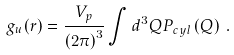Convert formula to latex. <formula><loc_0><loc_0><loc_500><loc_500>g _ { u } ( r ) = \frac { V _ { p } } { \left ( 2 \pi \right ) ^ { 3 } } \int d ^ { 3 } Q P _ { c y l } \left ( Q \right ) \, .</formula> 